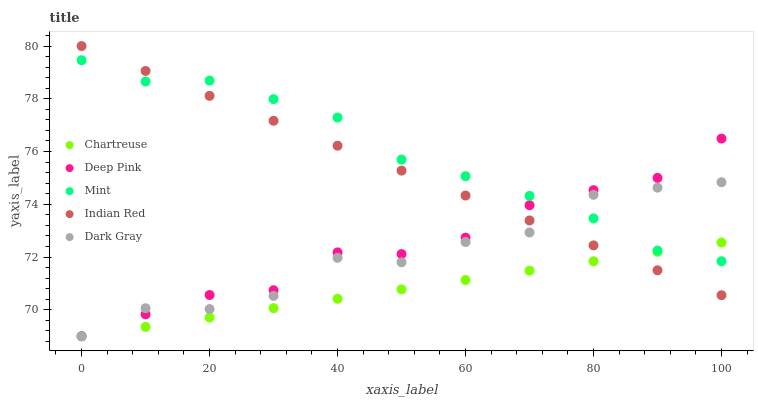Does Chartreuse have the minimum area under the curve?
Answer yes or no. Yes. Does Mint have the maximum area under the curve?
Answer yes or no. Yes. Does Deep Pink have the minimum area under the curve?
Answer yes or no. No. Does Deep Pink have the maximum area under the curve?
Answer yes or no. No. Is Indian Red the smoothest?
Answer yes or no. Yes. Is Dark Gray the roughest?
Answer yes or no. Yes. Is Chartreuse the smoothest?
Answer yes or no. No. Is Chartreuse the roughest?
Answer yes or no. No. Does Dark Gray have the lowest value?
Answer yes or no. Yes. Does Mint have the lowest value?
Answer yes or no. No. Does Indian Red have the highest value?
Answer yes or no. Yes. Does Deep Pink have the highest value?
Answer yes or no. No. Does Dark Gray intersect Chartreuse?
Answer yes or no. Yes. Is Dark Gray less than Chartreuse?
Answer yes or no. No. Is Dark Gray greater than Chartreuse?
Answer yes or no. No. 